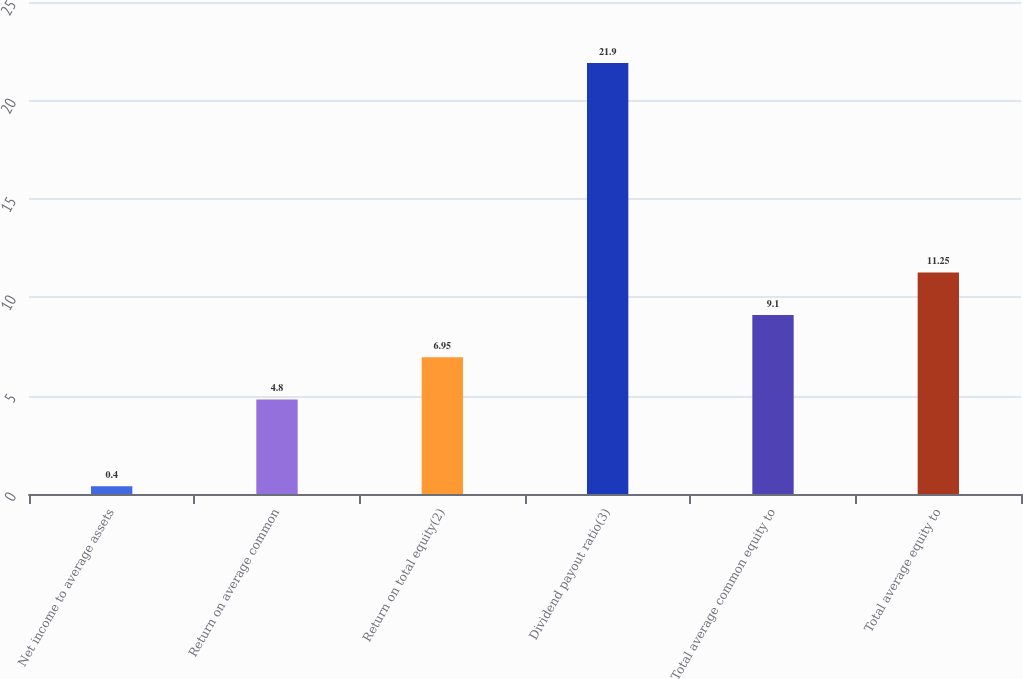Convert chart to OTSL. <chart><loc_0><loc_0><loc_500><loc_500><bar_chart><fcel>Net income to average assets<fcel>Return on average common<fcel>Return on total equity(2)<fcel>Dividend payout ratio(3)<fcel>Total average common equity to<fcel>Total average equity to<nl><fcel>0.4<fcel>4.8<fcel>6.95<fcel>21.9<fcel>9.1<fcel>11.25<nl></chart> 